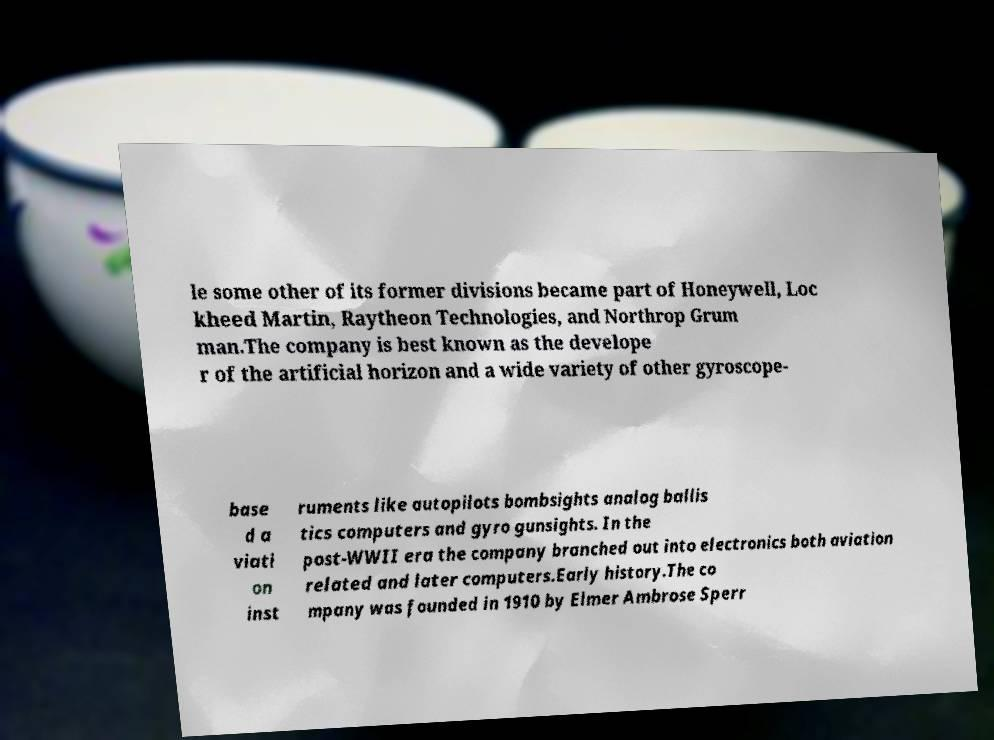I need the written content from this picture converted into text. Can you do that? le some other of its former divisions became part of Honeywell, Loc kheed Martin, Raytheon Technologies, and Northrop Grum man.The company is best known as the develope r of the artificial horizon and a wide variety of other gyroscope- base d a viati on inst ruments like autopilots bombsights analog ballis tics computers and gyro gunsights. In the post-WWII era the company branched out into electronics both aviation related and later computers.Early history.The co mpany was founded in 1910 by Elmer Ambrose Sperr 